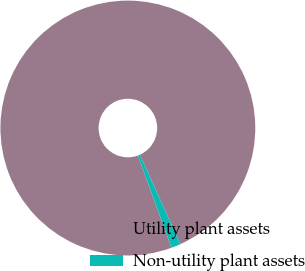Convert chart. <chart><loc_0><loc_0><loc_500><loc_500><pie_chart><fcel>Utility plant assets<fcel>Non-utility plant assets<nl><fcel>98.81%<fcel>1.19%<nl></chart> 